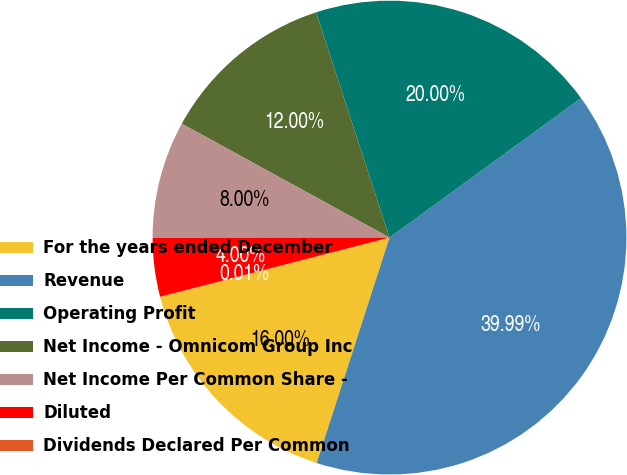Convert chart. <chart><loc_0><loc_0><loc_500><loc_500><pie_chart><fcel>For the years ended December<fcel>Revenue<fcel>Operating Profit<fcel>Net Income - Omnicom Group Inc<fcel>Net Income Per Common Share -<fcel>Diluted<fcel>Dividends Declared Per Common<nl><fcel>16.0%<fcel>39.99%<fcel>20.0%<fcel>12.0%<fcel>8.0%<fcel>4.0%<fcel>0.01%<nl></chart> 